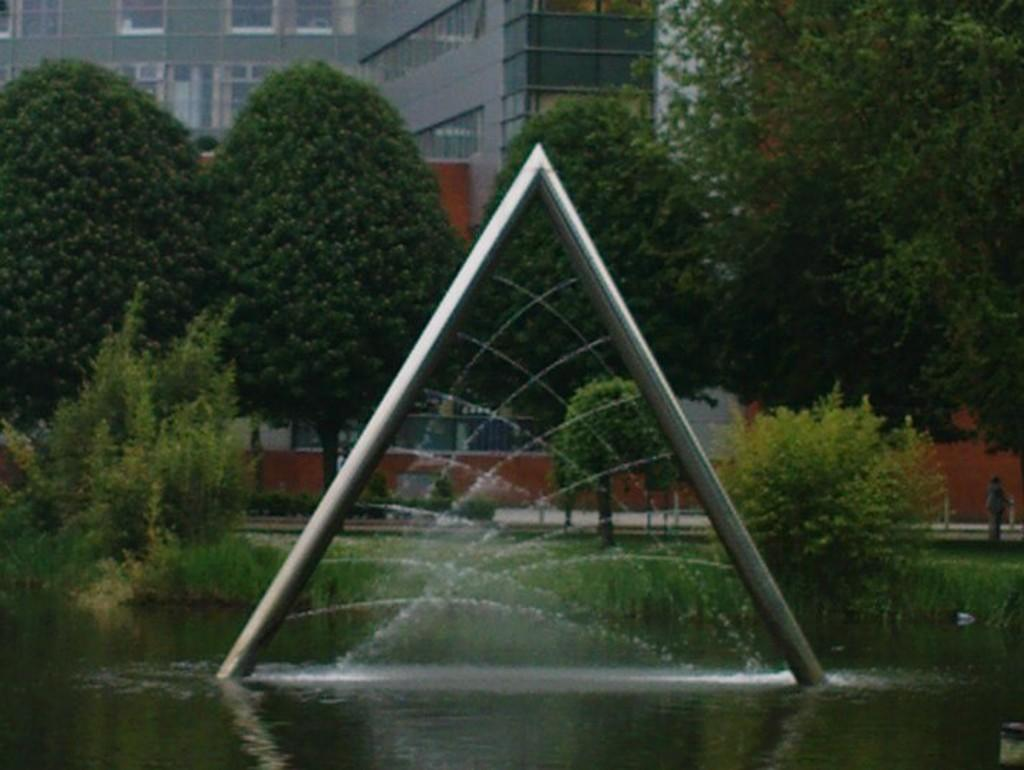What is the main feature in the center of the image? There is a fountain in the center of the image. What can be seen at the bottom of the image? There is water at the bottom of the image. What is visible in the background of the image? There is a building and trees in the background of the image. What scent can be detected coming from the fountain in the image? There is no information about the scent of the fountain in the image, as it is a visual representation. 